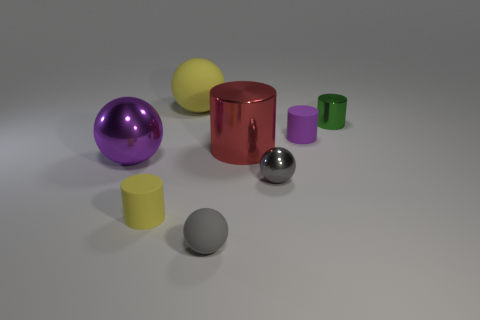How many other objects are the same size as the red cylinder?
Make the answer very short. 2. Are there the same number of cylinders that are behind the green cylinder and red spheres?
Offer a very short reply. Yes. Do the tiny sphere that is in front of the gray metal thing and the object that is behind the green metal cylinder have the same color?
Keep it short and to the point. No. What is the material of the small cylinder that is in front of the tiny green object and on the right side of the large yellow object?
Your answer should be compact. Rubber. What color is the big rubber sphere?
Give a very brief answer. Yellow. What number of other things are there of the same shape as the large matte thing?
Offer a terse response. 3. Is the number of matte spheres in front of the small gray shiny ball the same as the number of cylinders in front of the purple shiny object?
Offer a terse response. Yes. What is the material of the large yellow ball?
Offer a terse response. Rubber. What is the tiny cylinder in front of the tiny gray metal object made of?
Provide a short and direct response. Rubber. Is the number of balls in front of the large metal ball greater than the number of gray metal balls?
Provide a succinct answer. Yes. 